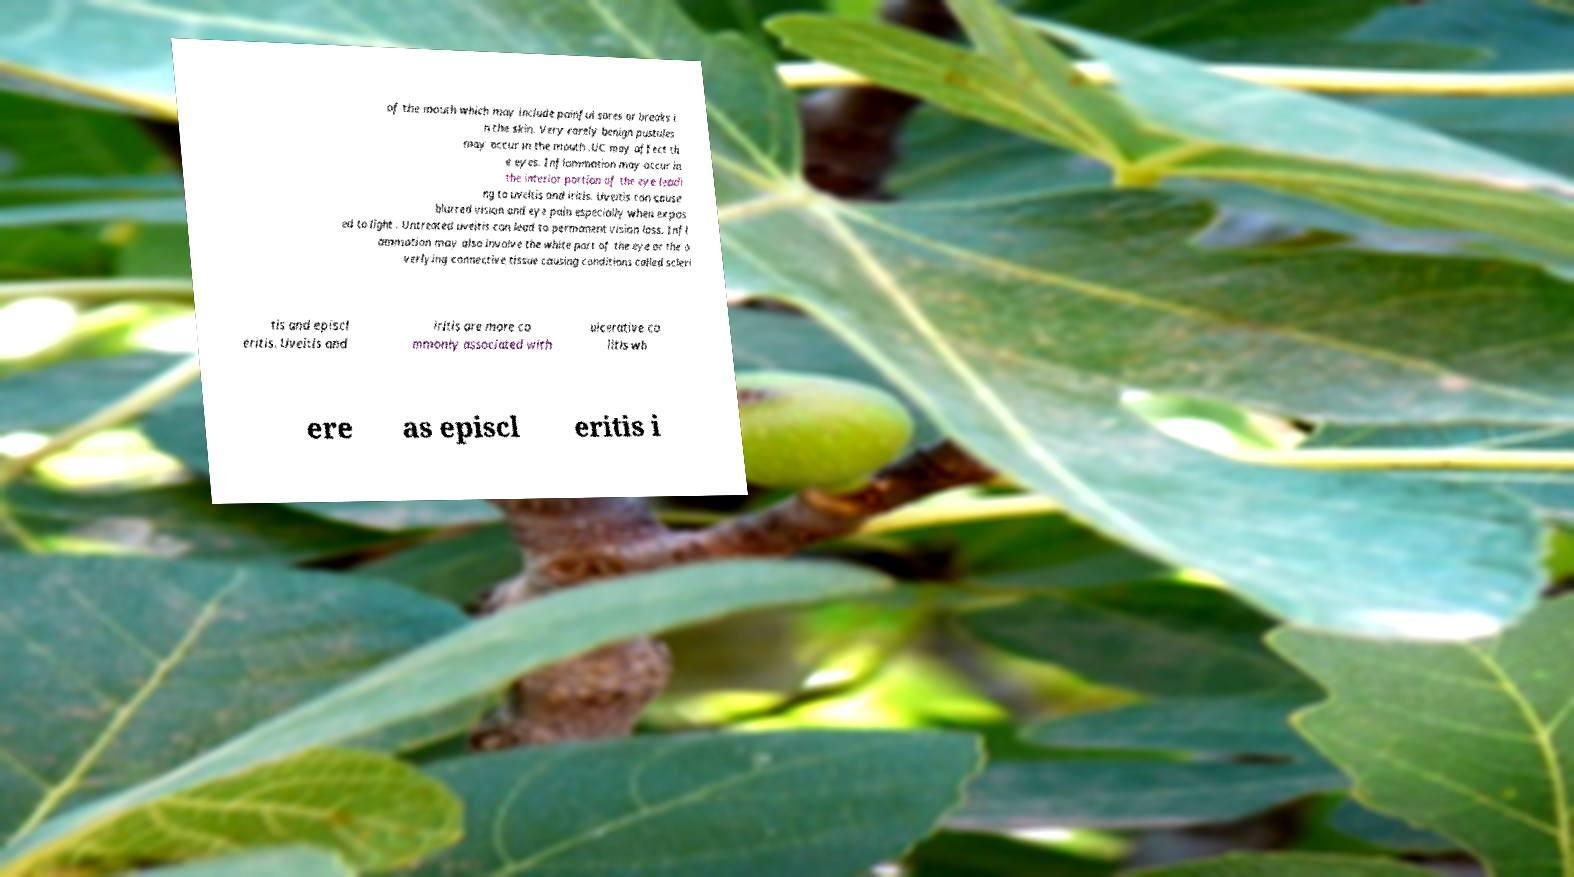Can you read and provide the text displayed in the image?This photo seems to have some interesting text. Can you extract and type it out for me? of the mouth which may include painful sores or breaks i n the skin. Very rarely benign pustules may occur in the mouth .UC may affect th e eyes. Inflammation may occur in the interior portion of the eye leadi ng to uveitis and iritis. Uveitis can cause blurred vision and eye pain especially when expos ed to light . Untreated uveitis can lead to permanent vision loss. Infl ammation may also involve the white part of the eye or the o verlying connective tissue causing conditions called scleri tis and episcl eritis. Uveitis and iritis are more co mmonly associated with ulcerative co litis wh ere as episcl eritis i 